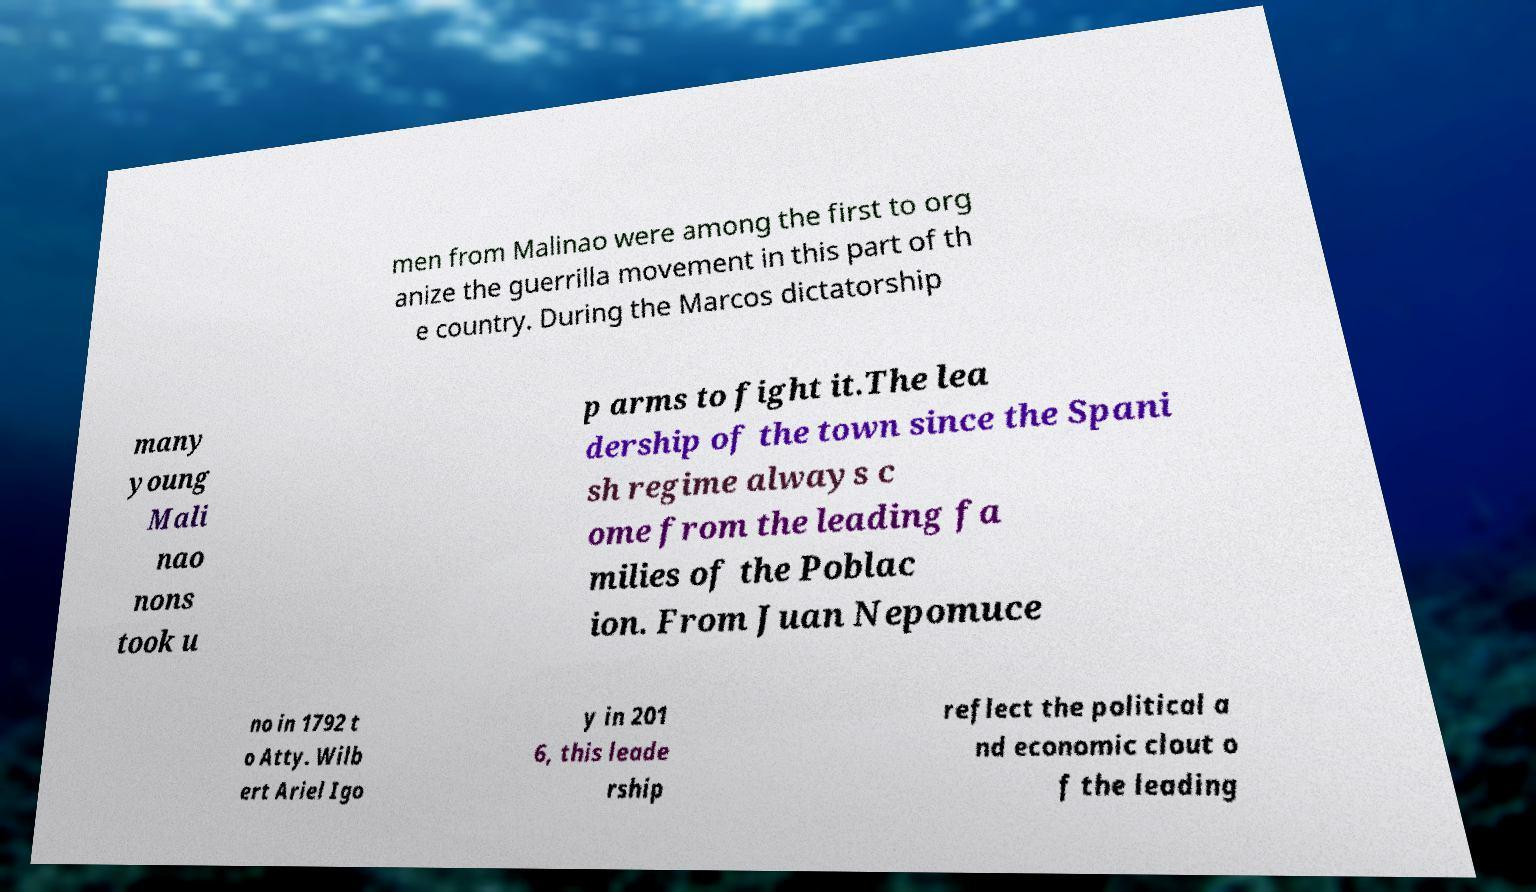Could you assist in decoding the text presented in this image and type it out clearly? men from Malinao were among the first to org anize the guerrilla movement in this part of th e country. During the Marcos dictatorship many young Mali nao nons took u p arms to fight it.The lea dership of the town since the Spani sh regime always c ome from the leading fa milies of the Poblac ion. From Juan Nepomuce no in 1792 t o Atty. Wilb ert Ariel Igo y in 201 6, this leade rship reflect the political a nd economic clout o f the leading 